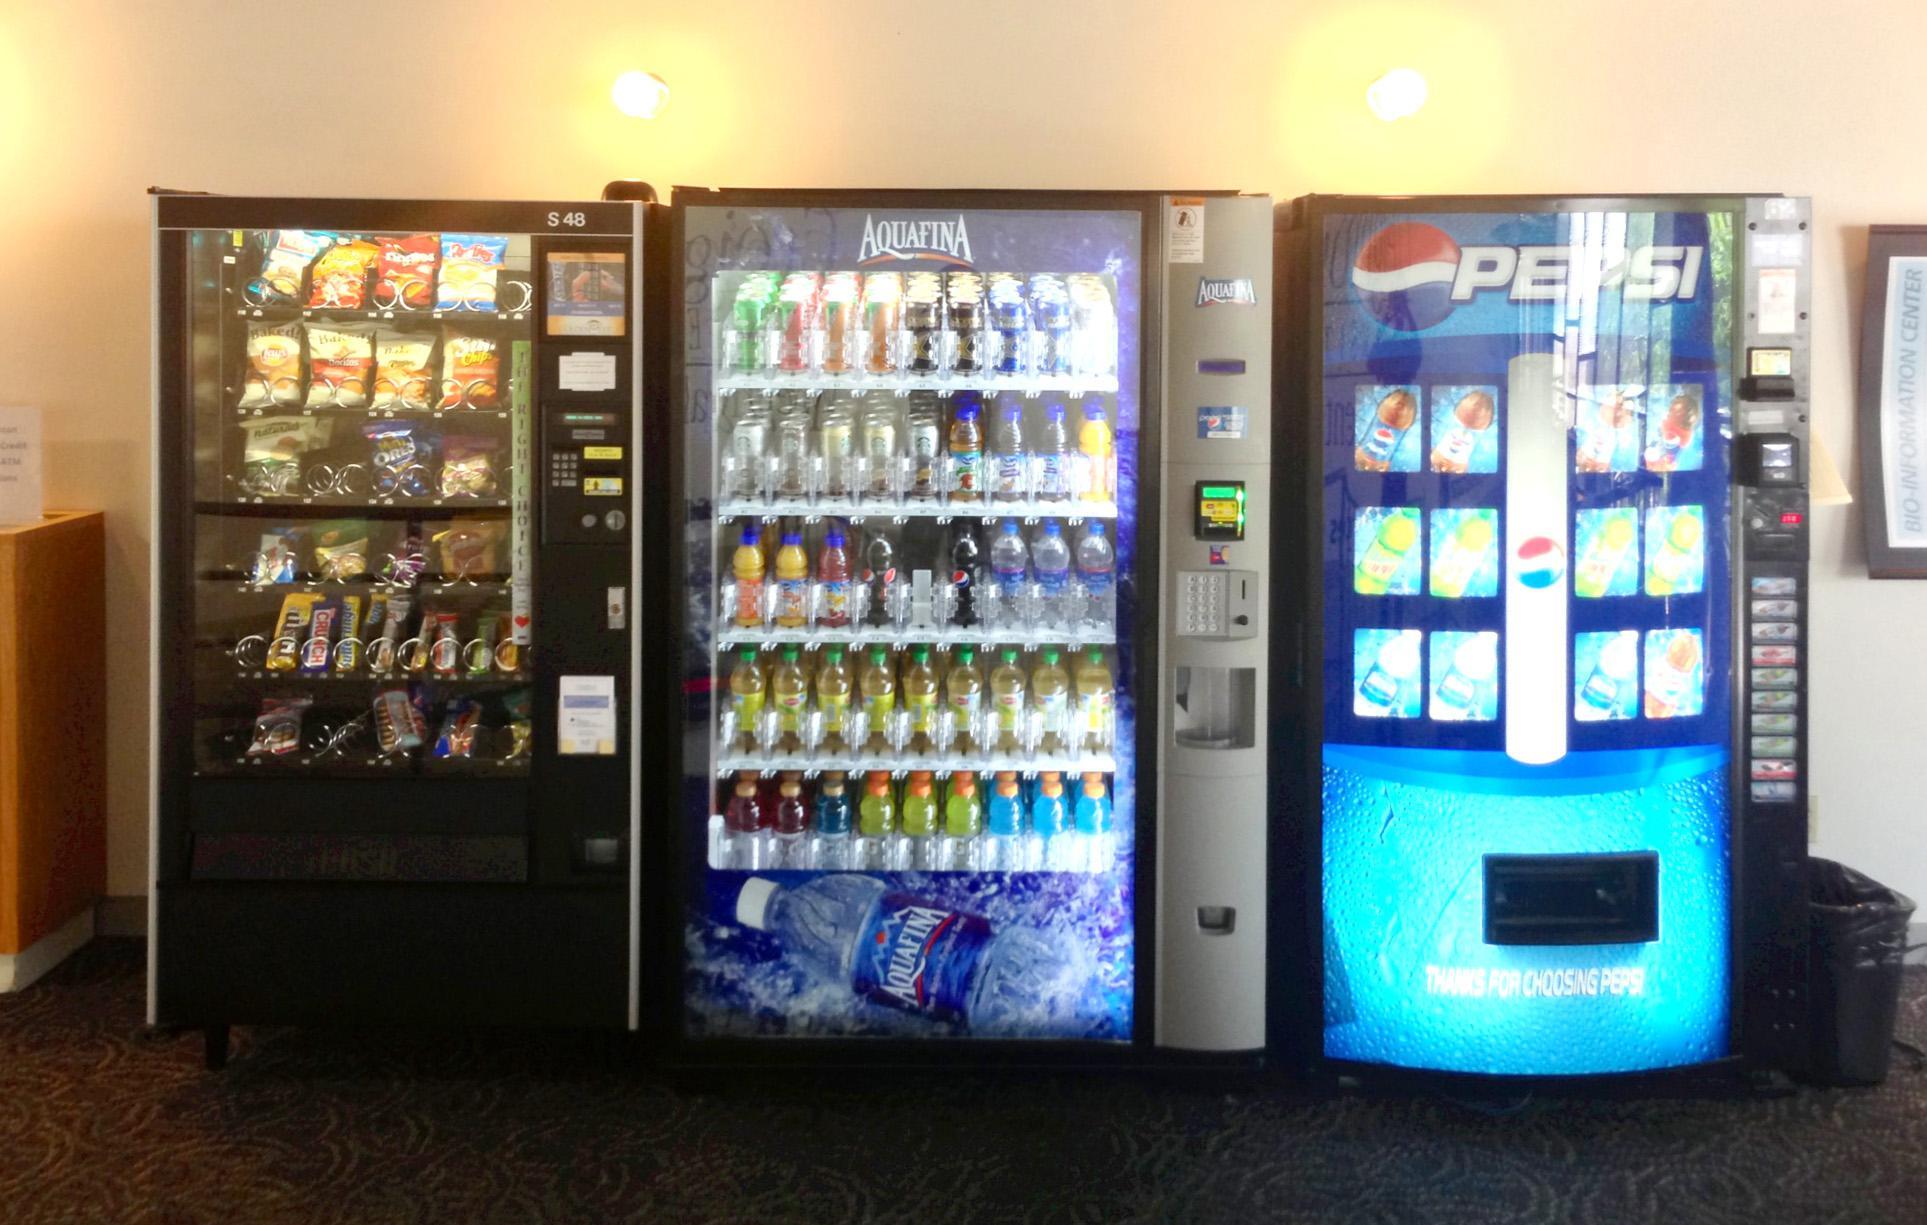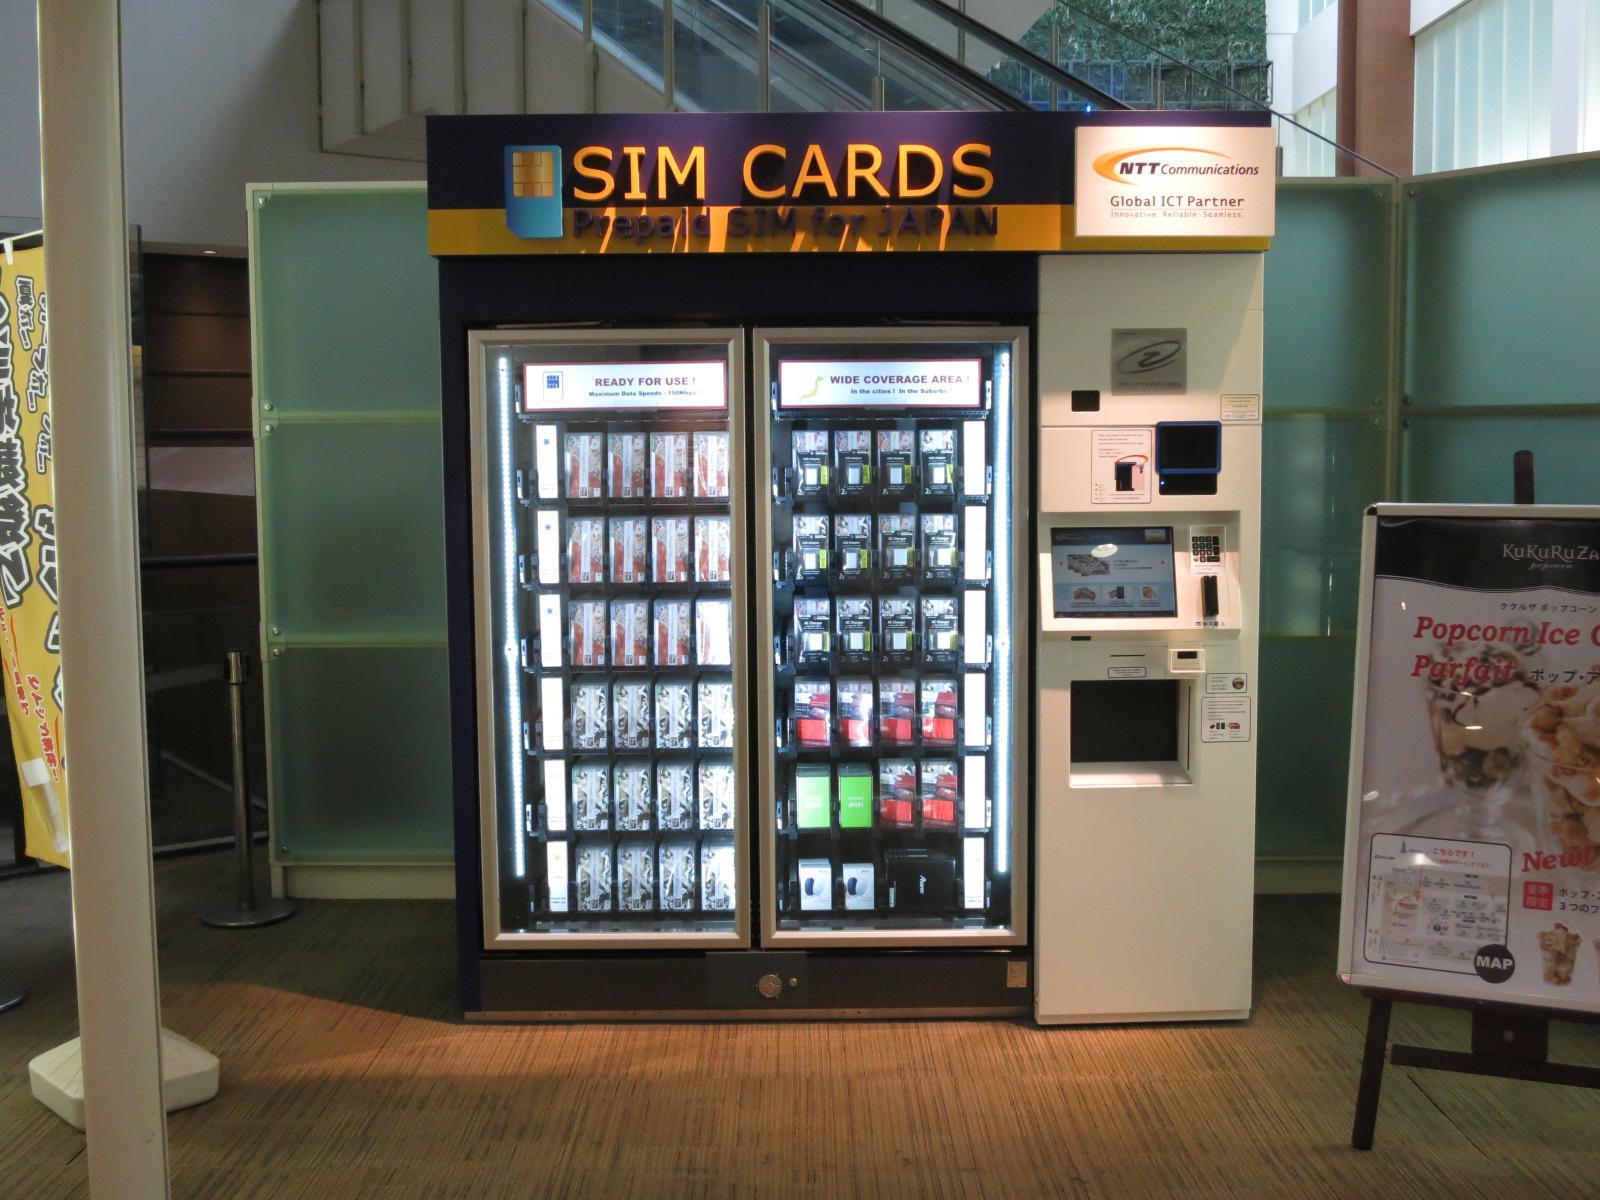The first image is the image on the left, the second image is the image on the right. Analyze the images presented: Is the assertion "At least one beverage vending machine has a blue 'wet look' front." valid? Answer yes or no. Yes. The first image is the image on the left, the second image is the image on the right. Assess this claim about the two images: "The left image contains at least one vending machine that is mostly blue in color.". Correct or not? Answer yes or no. Yes. 